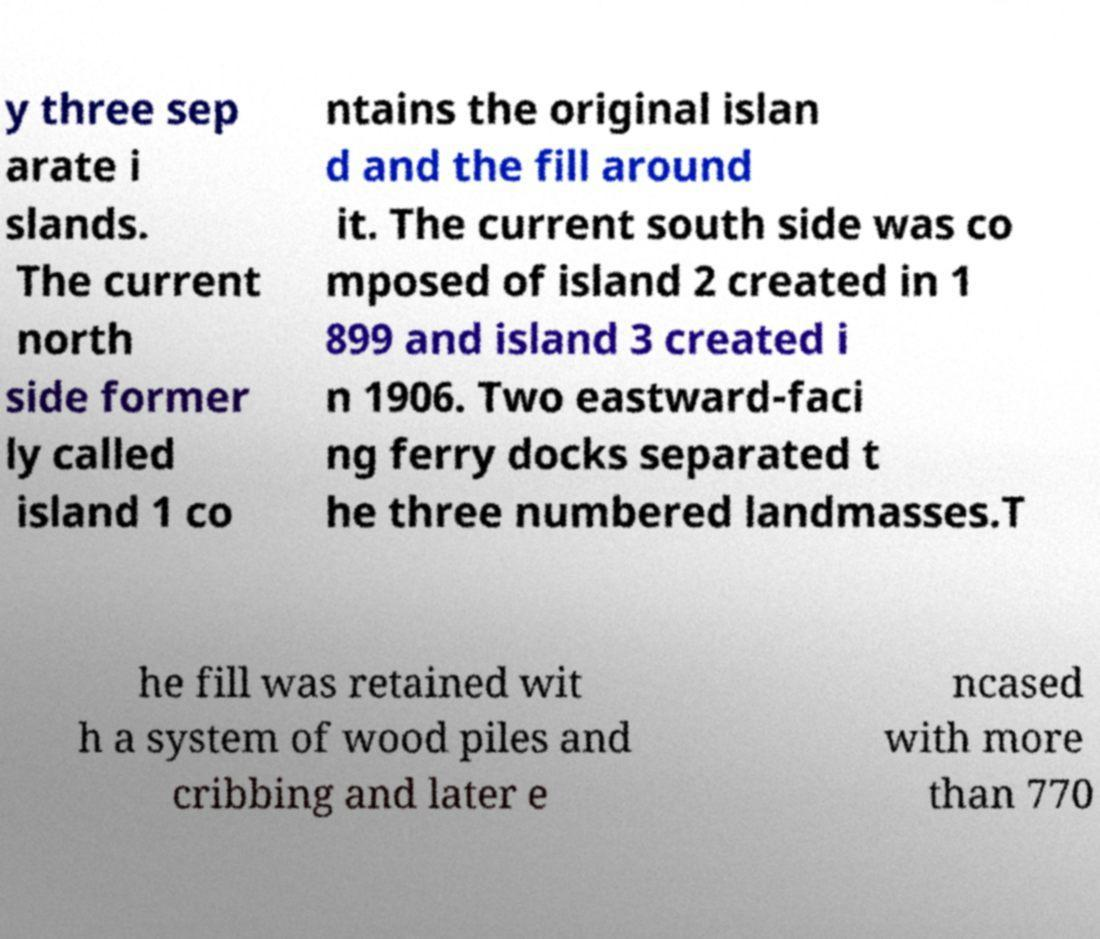Please read and relay the text visible in this image. What does it say? y three sep arate i slands. The current north side former ly called island 1 co ntains the original islan d and the fill around it. The current south side was co mposed of island 2 created in 1 899 and island 3 created i n 1906. Two eastward-faci ng ferry docks separated t he three numbered landmasses.T he fill was retained wit h a system of wood piles and cribbing and later e ncased with more than 770 